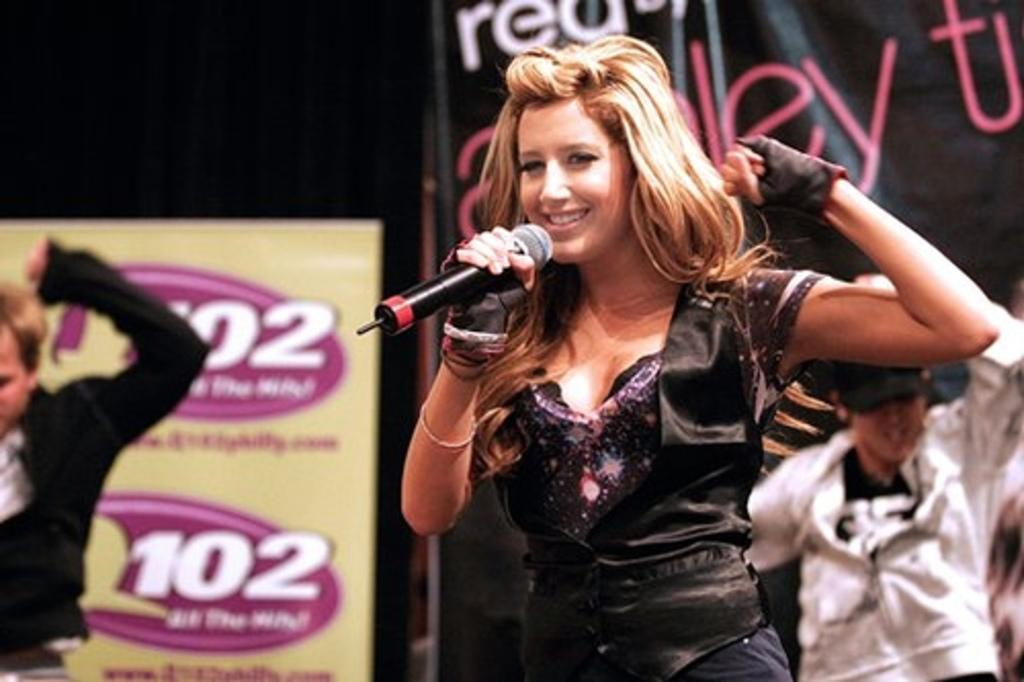What type of clothing is the woman wearing on her upper body in the image? The woman is wearing a black jacket in the image. What accessory is the woman wearing on her hands? The woman is wearing gloves in the image. What object is the woman holding in the image? The woman is holding a microphone in the image. Can you describe the people standing in the image? There are people standing in the image, but their specific characteristics are not mentioned in the provided facts. What can be seen in the background of the image? There are boards and banners in the background of the image. What type of bubble can be seen floating near the woman in the image? There is no bubble present in the image. Can you tell me how many grandmothers are visible in the image? The provided facts do not mention any grandmothers in the image. 